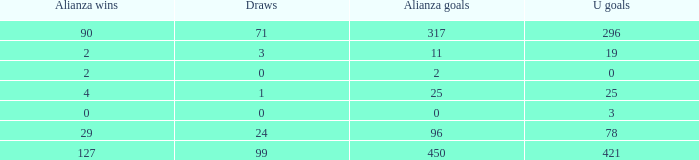Would you mind parsing the complete table? {'header': ['Alianza wins', 'Draws', 'Alianza goals', 'U goals'], 'rows': [['90', '71', '317', '296'], ['2', '3', '11', '19'], ['2', '0', '2', '0'], ['4', '1', '25', '25'], ['0', '0', '0', '3'], ['29', '24', '96', '78'], ['127', '99', '450', '421']]} What is the sum of Alianza Wins, when Alianza Goals is "317, and when U Goals is greater than 296? None. 